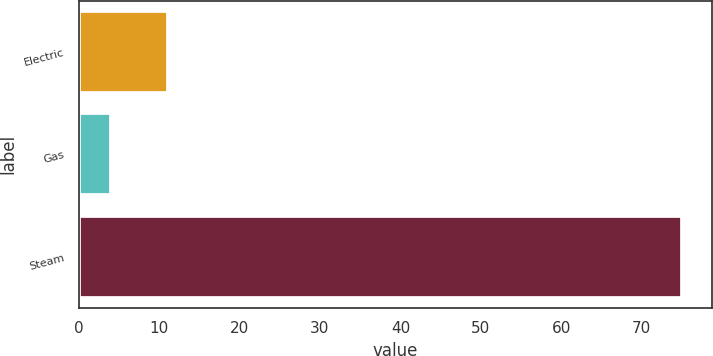Convert chart. <chart><loc_0><loc_0><loc_500><loc_500><bar_chart><fcel>Electric<fcel>Gas<fcel>Steam<nl><fcel>11.1<fcel>4<fcel>75<nl></chart> 